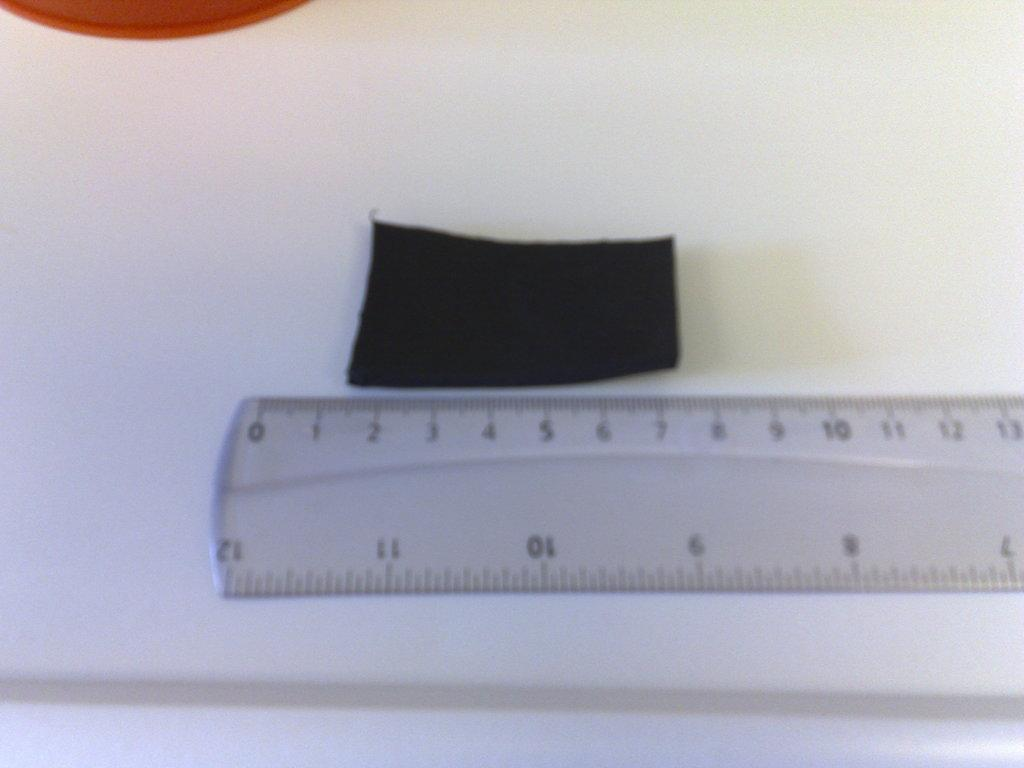<image>
Write a terse but informative summary of the picture. Something black being measured on a ruler between 1 and 7 centimeters. 